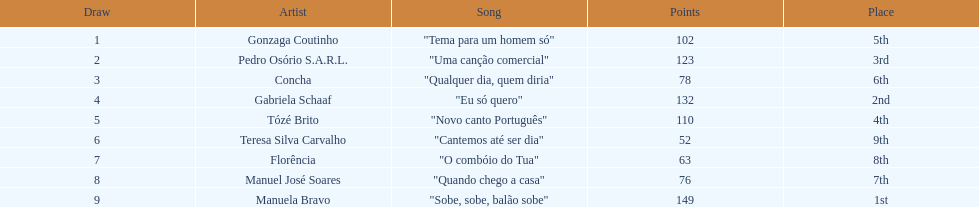Who secured the maximum points? Manuela Bravo. 